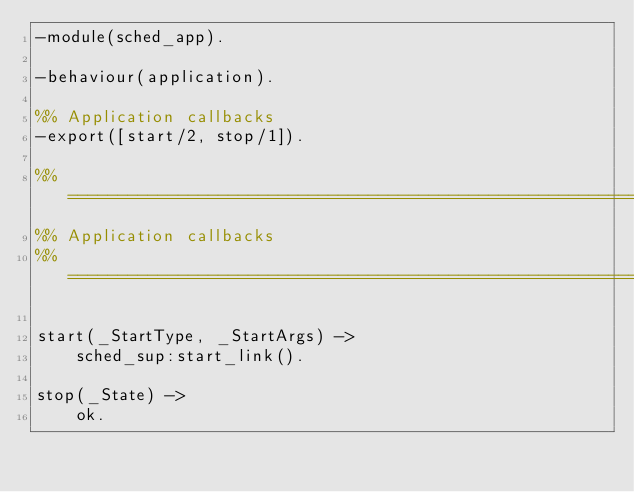<code> <loc_0><loc_0><loc_500><loc_500><_Erlang_>-module(sched_app).

-behaviour(application).

%% Application callbacks
-export([start/2, stop/1]).

%% ===================================================================
%% Application callbacks
%% ===================================================================

start(_StartType, _StartArgs) ->
    sched_sup:start_link().

stop(_State) ->
    ok.
</code> 